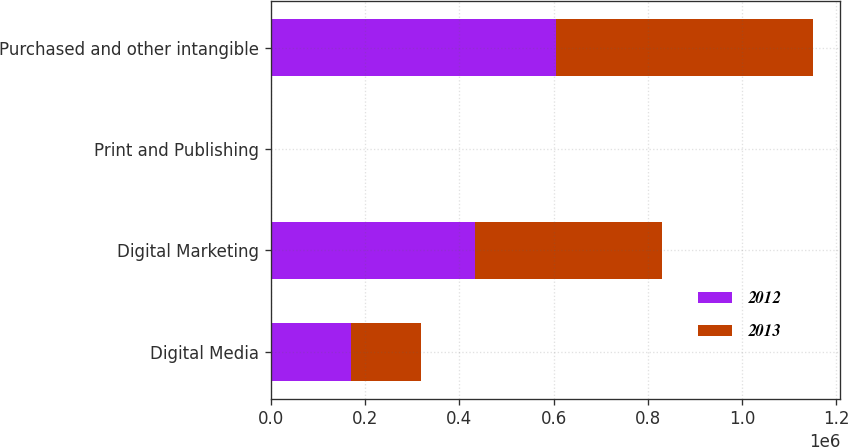Convert chart. <chart><loc_0><loc_0><loc_500><loc_500><stacked_bar_chart><ecel><fcel>Digital Media<fcel>Digital Marketing<fcel>Print and Publishing<fcel>Purchased and other intangible<nl><fcel>2012<fcel>170213<fcel>433245<fcel>1796<fcel>605254<nl><fcel>2013<fcel>148215<fcel>396786<fcel>35<fcel>545036<nl></chart> 